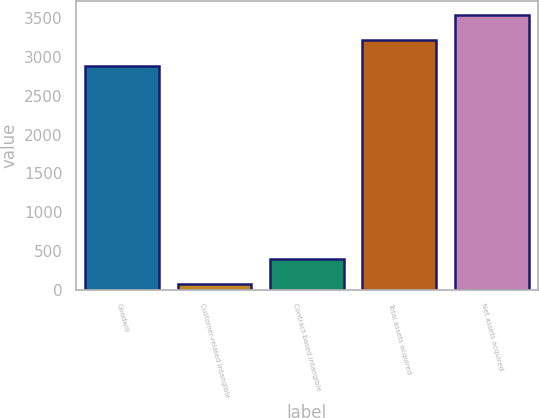Convert chart. <chart><loc_0><loc_0><loc_500><loc_500><bar_chart><fcel>Goodwill<fcel>Customer-related intangible<fcel>Contract-based intangible<fcel>Total assets acquired<fcel>Net assets acquired<nl><fcel>2887<fcel>78<fcel>392.8<fcel>3226<fcel>3540.8<nl></chart> 